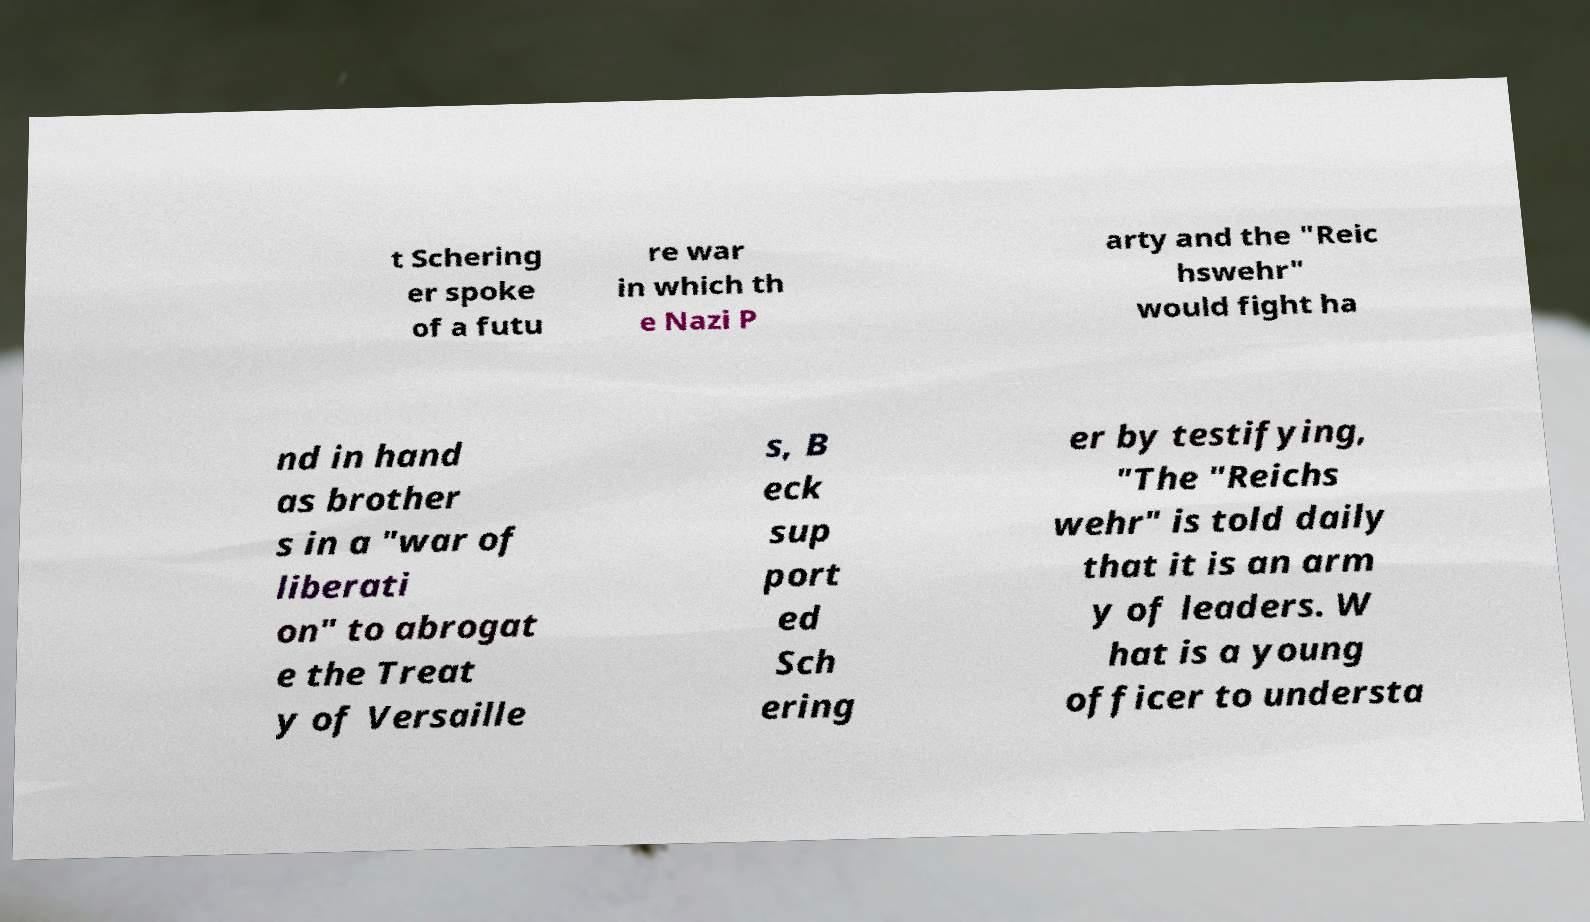What messages or text are displayed in this image? I need them in a readable, typed format. t Schering er spoke of a futu re war in which th e Nazi P arty and the "Reic hswehr" would fight ha nd in hand as brother s in a "war of liberati on" to abrogat e the Treat y of Versaille s, B eck sup port ed Sch ering er by testifying, "The "Reichs wehr" is told daily that it is an arm y of leaders. W hat is a young officer to understa 